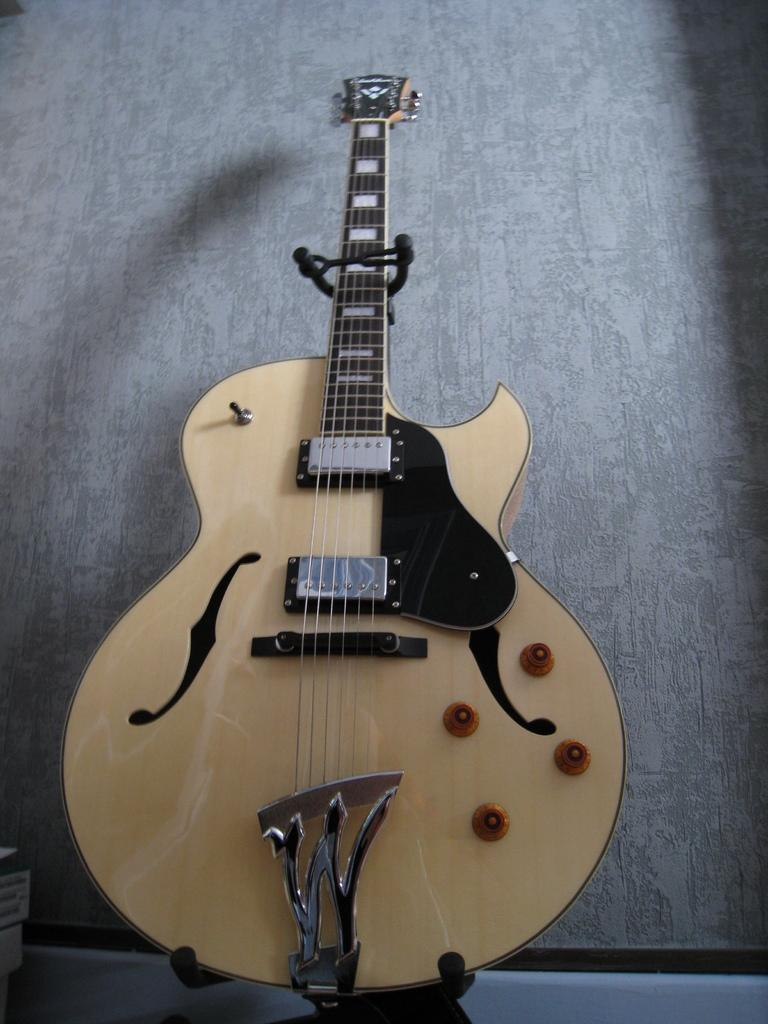What musical instrument is present in the image? There is a guitar in the image. How many strings does the guitar have? The guitar has six strings. Are there any additional features on the guitar? Yes, the guitar has four knobs. What type of manager is depicted holding the guitar in the image? There is no manager present in the image; it only features a guitar with six strings and four knobs. 